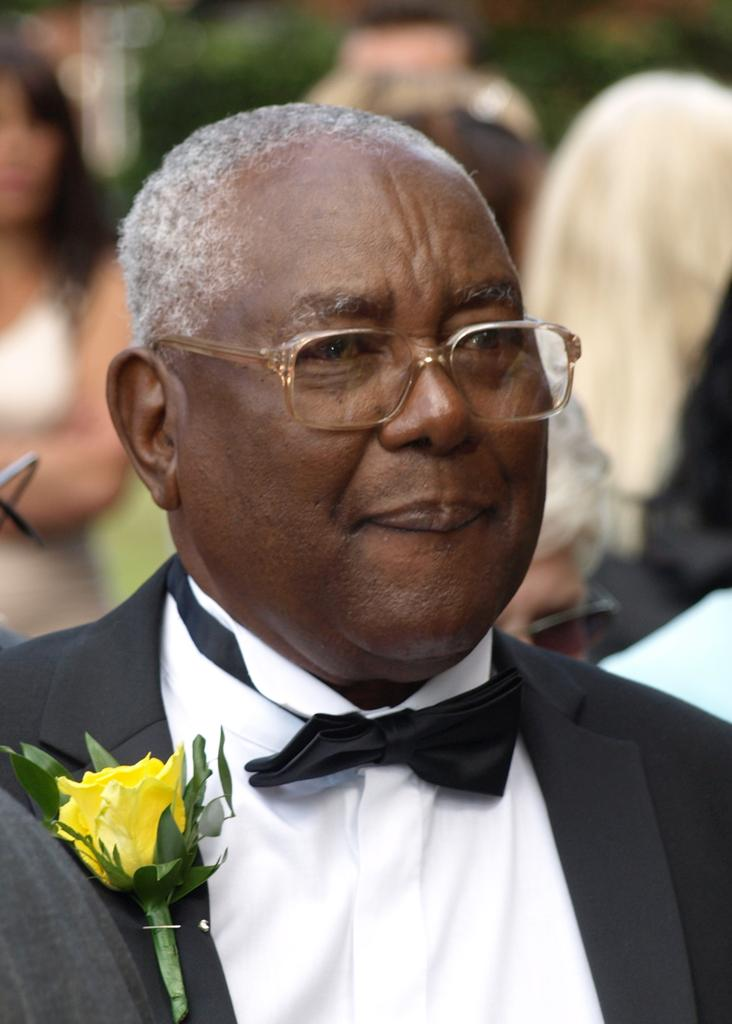What can be seen in the image? There is a person in the image. Can you describe the person's attire? The person is wearing a black and white dress. What other object is visible in the image? There is a yellow flower in the image. How would you describe the background of the image? The background of the image is blurred. What type of ship can be seen sailing in the background of the image? There is no ship visible in the image; it only features a person, a black and white dress, a yellow flower, and a blurred background. 